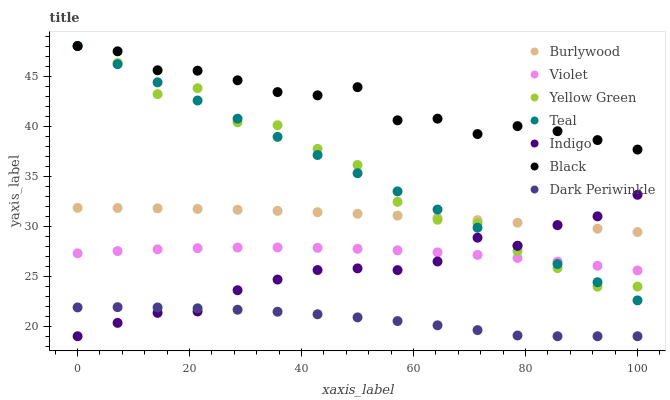Does Dark Periwinkle have the minimum area under the curve?
Answer yes or no. Yes. Does Black have the maximum area under the curve?
Answer yes or no. Yes. Does Yellow Green have the minimum area under the curve?
Answer yes or no. No. Does Yellow Green have the maximum area under the curve?
Answer yes or no. No. Is Teal the smoothest?
Answer yes or no. Yes. Is Yellow Green the roughest?
Answer yes or no. Yes. Is Burlywood the smoothest?
Answer yes or no. No. Is Burlywood the roughest?
Answer yes or no. No. Does Indigo have the lowest value?
Answer yes or no. Yes. Does Yellow Green have the lowest value?
Answer yes or no. No. Does Teal have the highest value?
Answer yes or no. Yes. Does Burlywood have the highest value?
Answer yes or no. No. Is Dark Periwinkle less than Black?
Answer yes or no. Yes. Is Black greater than Burlywood?
Answer yes or no. Yes. Does Teal intersect Burlywood?
Answer yes or no. Yes. Is Teal less than Burlywood?
Answer yes or no. No. Is Teal greater than Burlywood?
Answer yes or no. No. Does Dark Periwinkle intersect Black?
Answer yes or no. No. 